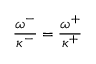Convert formula to latex. <formula><loc_0><loc_0><loc_500><loc_500>\frac { \omega ^ { - } } { \kappa ^ { - } } = \frac { \omega ^ { + } } { \kappa ^ { + } }</formula> 